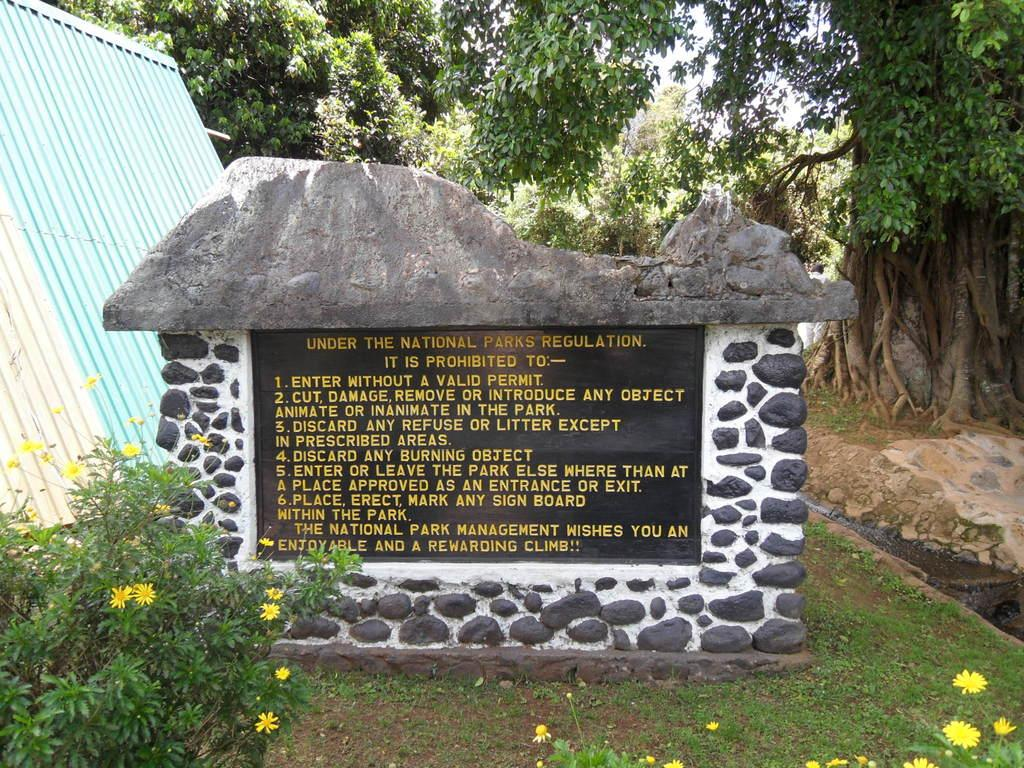What type of object can be seen in the image that provides information? There is an information stone in the image. What type of structure is present in the image? There is a shed in the image. What type of vegetation can be seen in the image? There are plants, flowers, grass, and trees in the image. What is visible on the ground in the image? The ground is visible in the image, and there are stones present. What part of the natural environment is visible in the image? The sky is visible in the image. Where is the sidewalk located in the image? There is no sidewalk present in the image. What type of fuel is being used by the plants in the image? Plants do not use fuel; they produce their own energy through photosynthesis. 